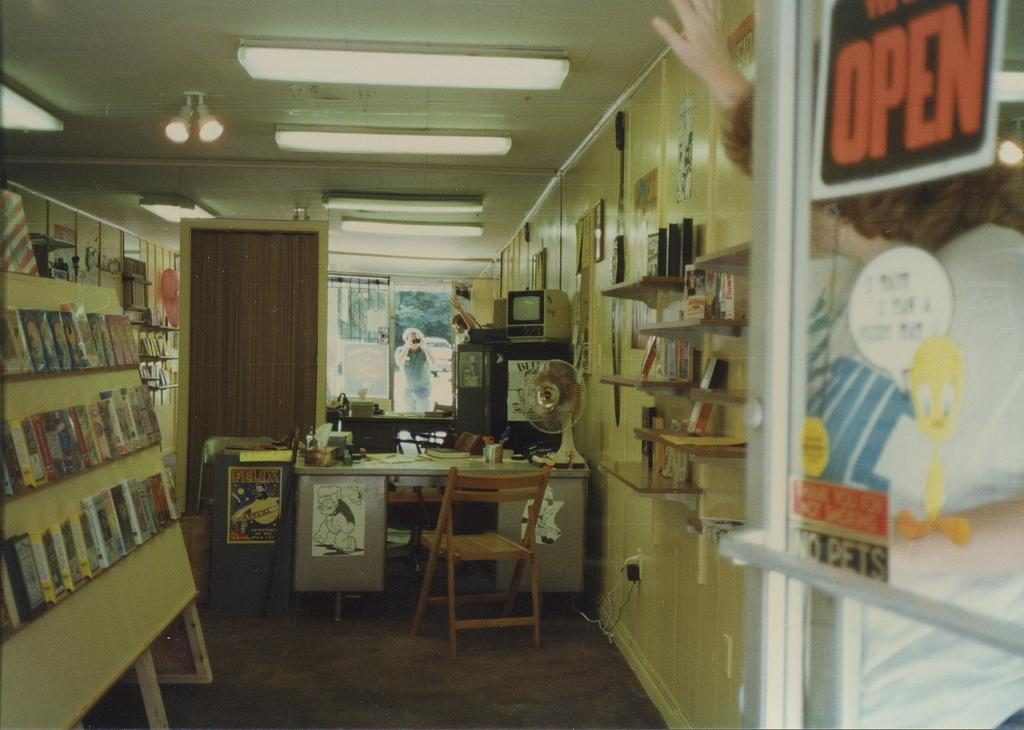<image>
Describe the image concisely. A woman holds up the door of a store with an open sign on it. 